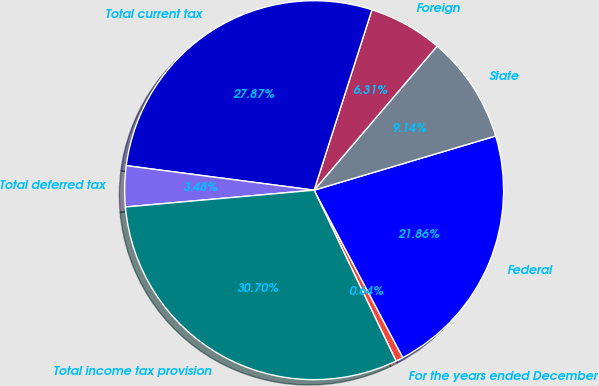Convert chart. <chart><loc_0><loc_0><loc_500><loc_500><pie_chart><fcel>For the years ended December<fcel>Federal<fcel>State<fcel>Foreign<fcel>Total current tax<fcel>Total deferred tax<fcel>Total income tax provision<nl><fcel>0.64%<fcel>21.86%<fcel>9.14%<fcel>6.31%<fcel>27.87%<fcel>3.48%<fcel>30.7%<nl></chart> 